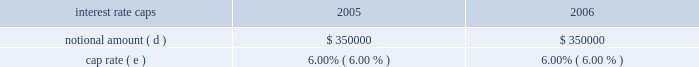Aggregate notional amounts associated with interest rate caps in place as of december 31 , 2004 and interest rate detail by contractual maturity dates ( in thousands , except percentages ) .
( a ) as of december 31 , 2005 , variable rate debt consists of the new american tower and spectrasite credit facilities ( $ 1493.0 million ) that were refinanced on october 27 , 2005 , which are included above based on their october 27 , 2010 maturity dates .
As of december 31 , 2005 , fixed rate debt consists of : the 2.25% ( 2.25 % ) convertible notes due 2009 ( 2.25% ( 2.25 % ) notes ) ( $ 0.1 million ) ; the 7.125% ( 7.125 % ) notes ( $ 500.0 million principal amount due at maturity ; the balance as of december 31 , 2005 is $ 501.9 million ) ; the 5.0% ( 5.0 % ) notes ( $ 275.7 million ) ; the 3.25% ( 3.25 % ) notes ( $ 152.9 million ) ; the 7.50% ( 7.50 % ) notes ( $ 225.0 million ) ; the ati 7.25% ( 7.25 % ) notes ( $ 400.0 million ) ; the ati 12.25% ( 12.25 % ) notes ( $ 227.7 million principal amount due at maturity ; the balance as of december 31 , 2005 is $ 160.3 million accreted value , net of the allocated fair value of the related warrants of $ 7.2 million ) ; the 3.00% ( 3.00 % ) notes ( $ 345.0 million principal amount due at maturity ; the balance as of december 31 , 2005 is $ 344.4 million accreted value ) and other debt of $ 60.4 million .
Interest on our credit facilities is payable in accordance with the applicable london interbank offering rate ( libor ) agreement or quarterly and accrues at our option either at libor plus margin ( as defined ) or the base rate plus margin ( as defined ) .
The weighted average interest rate in effect at december 31 , 2005 for our credit facilities was 4.71% ( 4.71 % ) .
For the year ended december 31 , 2005 , the weighted average interest rate under our credit facilities was 5.03% ( 5.03 % ) .
As of december 31 , 2004 , variable rate debt consists of our previous credit facility ( $ 698.0 million ) and fixed rate debt consists of : the 2.25% ( 2.25 % ) notes ( $ 0.1 million ) ; the 7.125% ( 7.125 % ) notes ( $ 500.0 million principal amount due at maturity ; the balance as of december 31 , 2004 is $ 501.9 million ) ; the 5.0% ( 5.0 % ) notes ( $ 275.7 million ) ; the 3.25% ( 3.25 % ) notes ( $ 210.0 million ) ; the 7.50% ( 7.50 % ) notes ( $ 225.0 million ) ; the ati 7.25% ( 7.25 % ) notes ( $ 400.0 million ) ; the ati 12.25% ( 12.25 % ) notes ( $ 498.3 million principal amount due at maturity ; the balance as of december 31 , 2004 is $ 303.8 million accreted value , net of the allocated fair value of the related warrants of $ 21.6 million ) ; the 9 3 20448% ( 20448 % ) notes ( $ 274.9 million ) ; the 3.00% ( 3.00 % ) notes ( $ 345.0 million principal amount due at maturity ; the balance as of december 31 , 2004 is $ 344.3 million accreted value ) and other debt of $ 60.0 million .
Interest on the credit facility was payable in accordance with the applicable london interbank offering rate ( libor ) agreement or quarterly and accrues at our option either at libor plus margin ( as defined ) or the base rate plus margin ( as defined ) .
The weighted average interest rate in effect at december 31 , 2004 for the credit facility was 4.35% ( 4.35 % ) .
For the year ended december 31 , 2004 , the weighted average interest rate under the credit facility was 3.81% ( 3.81 % ) .
( b ) includes notional amount of $ 175000 that expires in february 2006 .
( c ) includes notional amount of $ 25000 that expires in september 2007 .
( d ) includes notional amounts of $ 250000 and $ 100000 that expire in june and july 2006 , respectively .
( e ) represents the weighted-average fixed rate or range of interest based on contractual notional amount as a percentage of total notional amounts in a given year .
( f ) includes notional amounts of $ 75000 , $ 75000 and $ 150000 that expire in december 2009 .
( g ) includes notional amounts of $ 100000 , $ 50000 , $ 50000 , $ 50000 and $ 50000 that expire in october 2010 .
( h ) includes notional amounts of $ 50000 and $ 50000 that expire in october 2010 .
( i ) includes notional amount of $ 50000 that expires in october 2010 .
Our foreign operations include rental and management segment divisions in mexico and brazil .
The remeasurement gain for the year ended december 31 , 2005 was $ 396000 , and the remeasurement losses for the years ended december 31 , 2004 , and 2003 approximated $ 146000 , and $ 1142000 , respectively .
Changes in interest rates can cause interest charges to fluctuate on our variable rate debt , comprised of $ 1493.0 million under our credit facilities as of december 31 , 2005 .
A 10% ( 10 % ) increase , or approximately 47 basis points , in current interest rates would have caused an additional pre-tax charge our net loss and an increase in our cash outflows of $ 7.0 million for the year ended december 31 , 2005 .
Item 8 .
Financial statements and supplementary data see item 15 ( a ) .
Item 9 .
Changes in and disagreements with accountants on accounting and financial disclosure .
What is the annual interest expense related to the 7.125% ( 7.125 % ) notes , in millions? 
Computations: (7.125% * 500.0)
Answer: 35.625. Aggregate notional amounts associated with interest rate caps in place as of december 31 , 2004 and interest rate detail by contractual maturity dates ( in thousands , except percentages ) .
( a ) as of december 31 , 2005 , variable rate debt consists of the new american tower and spectrasite credit facilities ( $ 1493.0 million ) that were refinanced on october 27 , 2005 , which are included above based on their october 27 , 2010 maturity dates .
As of december 31 , 2005 , fixed rate debt consists of : the 2.25% ( 2.25 % ) convertible notes due 2009 ( 2.25% ( 2.25 % ) notes ) ( $ 0.1 million ) ; the 7.125% ( 7.125 % ) notes ( $ 500.0 million principal amount due at maturity ; the balance as of december 31 , 2005 is $ 501.9 million ) ; the 5.0% ( 5.0 % ) notes ( $ 275.7 million ) ; the 3.25% ( 3.25 % ) notes ( $ 152.9 million ) ; the 7.50% ( 7.50 % ) notes ( $ 225.0 million ) ; the ati 7.25% ( 7.25 % ) notes ( $ 400.0 million ) ; the ati 12.25% ( 12.25 % ) notes ( $ 227.7 million principal amount due at maturity ; the balance as of december 31 , 2005 is $ 160.3 million accreted value , net of the allocated fair value of the related warrants of $ 7.2 million ) ; the 3.00% ( 3.00 % ) notes ( $ 345.0 million principal amount due at maturity ; the balance as of december 31 , 2005 is $ 344.4 million accreted value ) and other debt of $ 60.4 million .
Interest on our credit facilities is payable in accordance with the applicable london interbank offering rate ( libor ) agreement or quarterly and accrues at our option either at libor plus margin ( as defined ) or the base rate plus margin ( as defined ) .
The weighted average interest rate in effect at december 31 , 2005 for our credit facilities was 4.71% ( 4.71 % ) .
For the year ended december 31 , 2005 , the weighted average interest rate under our credit facilities was 5.03% ( 5.03 % ) .
As of december 31 , 2004 , variable rate debt consists of our previous credit facility ( $ 698.0 million ) and fixed rate debt consists of : the 2.25% ( 2.25 % ) notes ( $ 0.1 million ) ; the 7.125% ( 7.125 % ) notes ( $ 500.0 million principal amount due at maturity ; the balance as of december 31 , 2004 is $ 501.9 million ) ; the 5.0% ( 5.0 % ) notes ( $ 275.7 million ) ; the 3.25% ( 3.25 % ) notes ( $ 210.0 million ) ; the 7.50% ( 7.50 % ) notes ( $ 225.0 million ) ; the ati 7.25% ( 7.25 % ) notes ( $ 400.0 million ) ; the ati 12.25% ( 12.25 % ) notes ( $ 498.3 million principal amount due at maturity ; the balance as of december 31 , 2004 is $ 303.8 million accreted value , net of the allocated fair value of the related warrants of $ 21.6 million ) ; the 9 3 20448% ( 20448 % ) notes ( $ 274.9 million ) ; the 3.00% ( 3.00 % ) notes ( $ 345.0 million principal amount due at maturity ; the balance as of december 31 , 2004 is $ 344.3 million accreted value ) and other debt of $ 60.0 million .
Interest on the credit facility was payable in accordance with the applicable london interbank offering rate ( libor ) agreement or quarterly and accrues at our option either at libor plus margin ( as defined ) or the base rate plus margin ( as defined ) .
The weighted average interest rate in effect at december 31 , 2004 for the credit facility was 4.35% ( 4.35 % ) .
For the year ended december 31 , 2004 , the weighted average interest rate under the credit facility was 3.81% ( 3.81 % ) .
( b ) includes notional amount of $ 175000 that expires in february 2006 .
( c ) includes notional amount of $ 25000 that expires in september 2007 .
( d ) includes notional amounts of $ 250000 and $ 100000 that expire in june and july 2006 , respectively .
( e ) represents the weighted-average fixed rate or range of interest based on contractual notional amount as a percentage of total notional amounts in a given year .
( f ) includes notional amounts of $ 75000 , $ 75000 and $ 150000 that expire in december 2009 .
( g ) includes notional amounts of $ 100000 , $ 50000 , $ 50000 , $ 50000 and $ 50000 that expire in october 2010 .
( h ) includes notional amounts of $ 50000 and $ 50000 that expire in october 2010 .
( i ) includes notional amount of $ 50000 that expires in october 2010 .
Our foreign operations include rental and management segment divisions in mexico and brazil .
The remeasurement gain for the year ended december 31 , 2005 was $ 396000 , and the remeasurement losses for the years ended december 31 , 2004 , and 2003 approximated $ 146000 , and $ 1142000 , respectively .
Changes in interest rates can cause interest charges to fluctuate on our variable rate debt , comprised of $ 1493.0 million under our credit facilities as of december 31 , 2005 .
A 10% ( 10 % ) increase , or approximately 47 basis points , in current interest rates would have caused an additional pre-tax charge our net loss and an increase in our cash outflows of $ 7.0 million for the year ended december 31 , 2005 .
Item 8 .
Financial statements and supplementary data see item 15 ( a ) .
Item 9 .
Changes in and disagreements with accountants on accounting and financial disclosure .
What is the annual interest expense related to the ati 7.25% ( 7.25 % ) notes , in millions? 
Computations: (400.0 * 7.25%)
Answer: 29.0. 